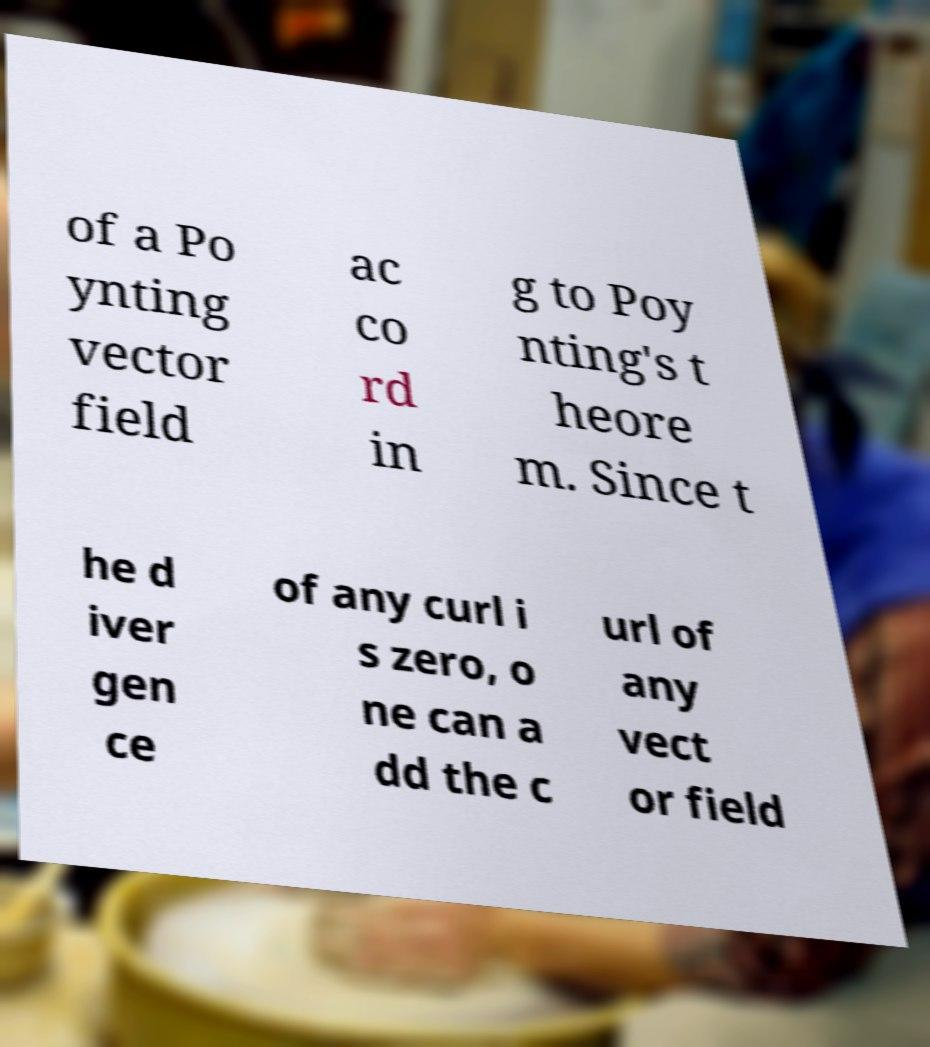There's text embedded in this image that I need extracted. Can you transcribe it verbatim? of a Po ynting vector field ac co rd in g to Poy nting's t heore m. Since t he d iver gen ce of any curl i s zero, o ne can a dd the c url of any vect or field 